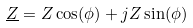<formula> <loc_0><loc_0><loc_500><loc_500>\underline { Z } = Z \cos ( \phi ) + j Z \sin ( \phi )</formula> 